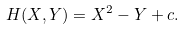Convert formula to latex. <formula><loc_0><loc_0><loc_500><loc_500>H ( X , Y ) = X ^ { 2 } - Y + c .</formula> 